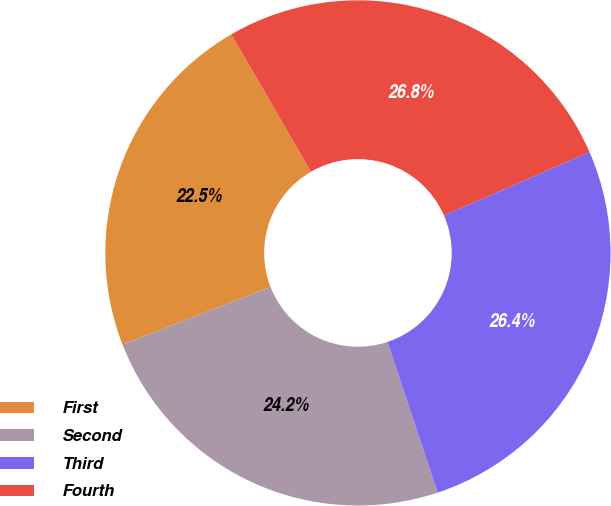<chart> <loc_0><loc_0><loc_500><loc_500><pie_chart><fcel>First<fcel>Second<fcel>Third<fcel>Fourth<nl><fcel>22.55%<fcel>24.2%<fcel>26.43%<fcel>26.82%<nl></chart> 